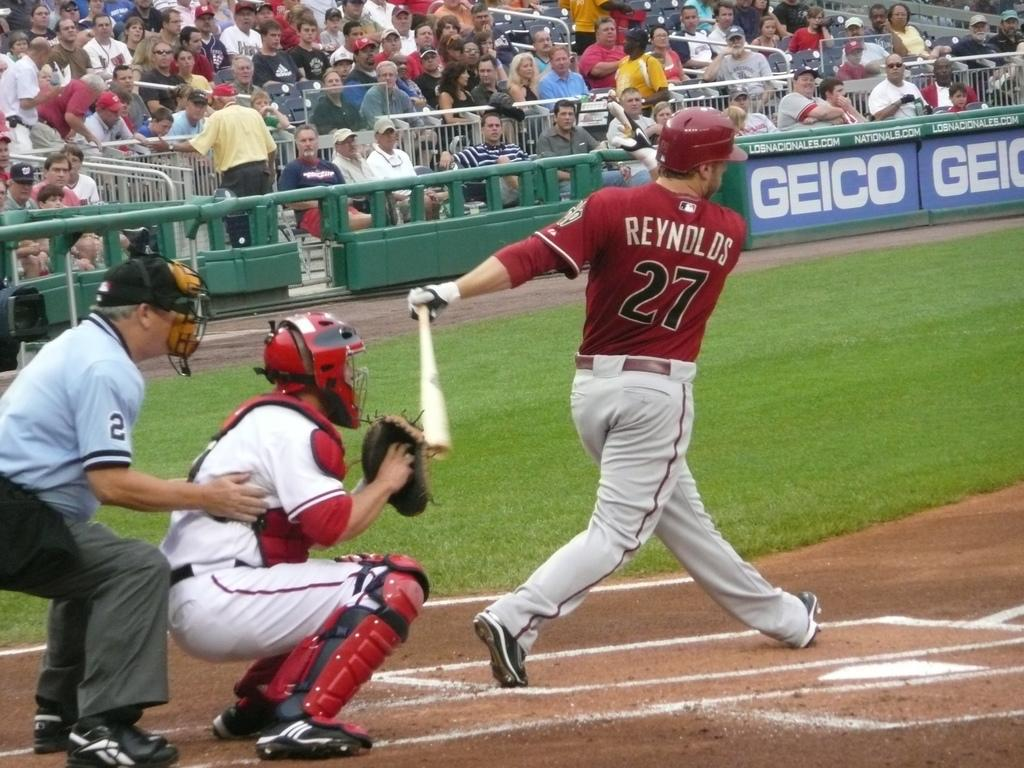<image>
Share a concise interpretation of the image provided. A baseball player wearing jersey number 27 completes a swing with his bat. 